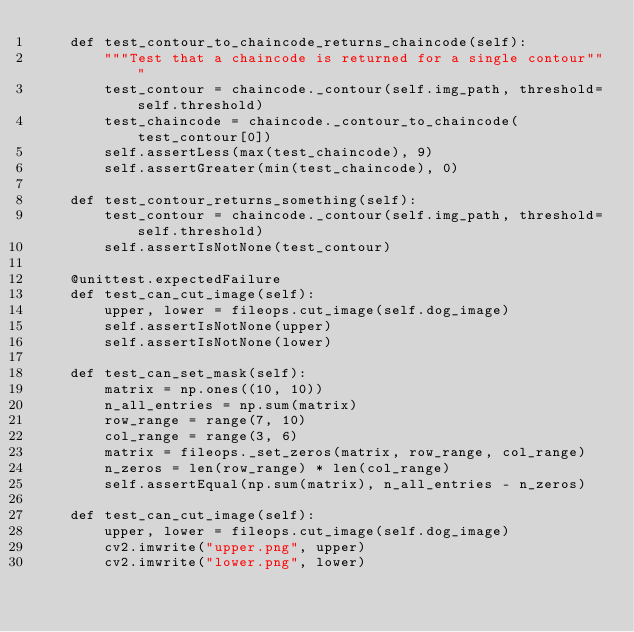<code> <loc_0><loc_0><loc_500><loc_500><_Python_>    def test_contour_to_chaincode_returns_chaincode(self):
        """Test that a chaincode is returned for a single contour"""
        test_contour = chaincode._contour(self.img_path, threshold=self.threshold)
        test_chaincode = chaincode._contour_to_chaincode(test_contour[0])
        self.assertLess(max(test_chaincode), 9)
        self.assertGreater(min(test_chaincode), 0)

    def test_contour_returns_something(self):
        test_contour = chaincode._contour(self.img_path, threshold=self.threshold)
        self.assertIsNotNone(test_contour)

    @unittest.expectedFailure
    def test_can_cut_image(self):
        upper, lower = fileops.cut_image(self.dog_image)
        self.assertIsNotNone(upper)
        self.assertIsNotNone(lower)

    def test_can_set_mask(self):
        matrix = np.ones((10, 10))
        n_all_entries = np.sum(matrix)
        row_range = range(7, 10)
        col_range = range(3, 6)
        matrix = fileops._set_zeros(matrix, row_range, col_range)
        n_zeros = len(row_range) * len(col_range)
        self.assertEqual(np.sum(matrix), n_all_entries - n_zeros)

    def test_can_cut_image(self):
        upper, lower = fileops.cut_image(self.dog_image)
        cv2.imwrite("upper.png", upper)
        cv2.imwrite("lower.png", lower)
</code> 